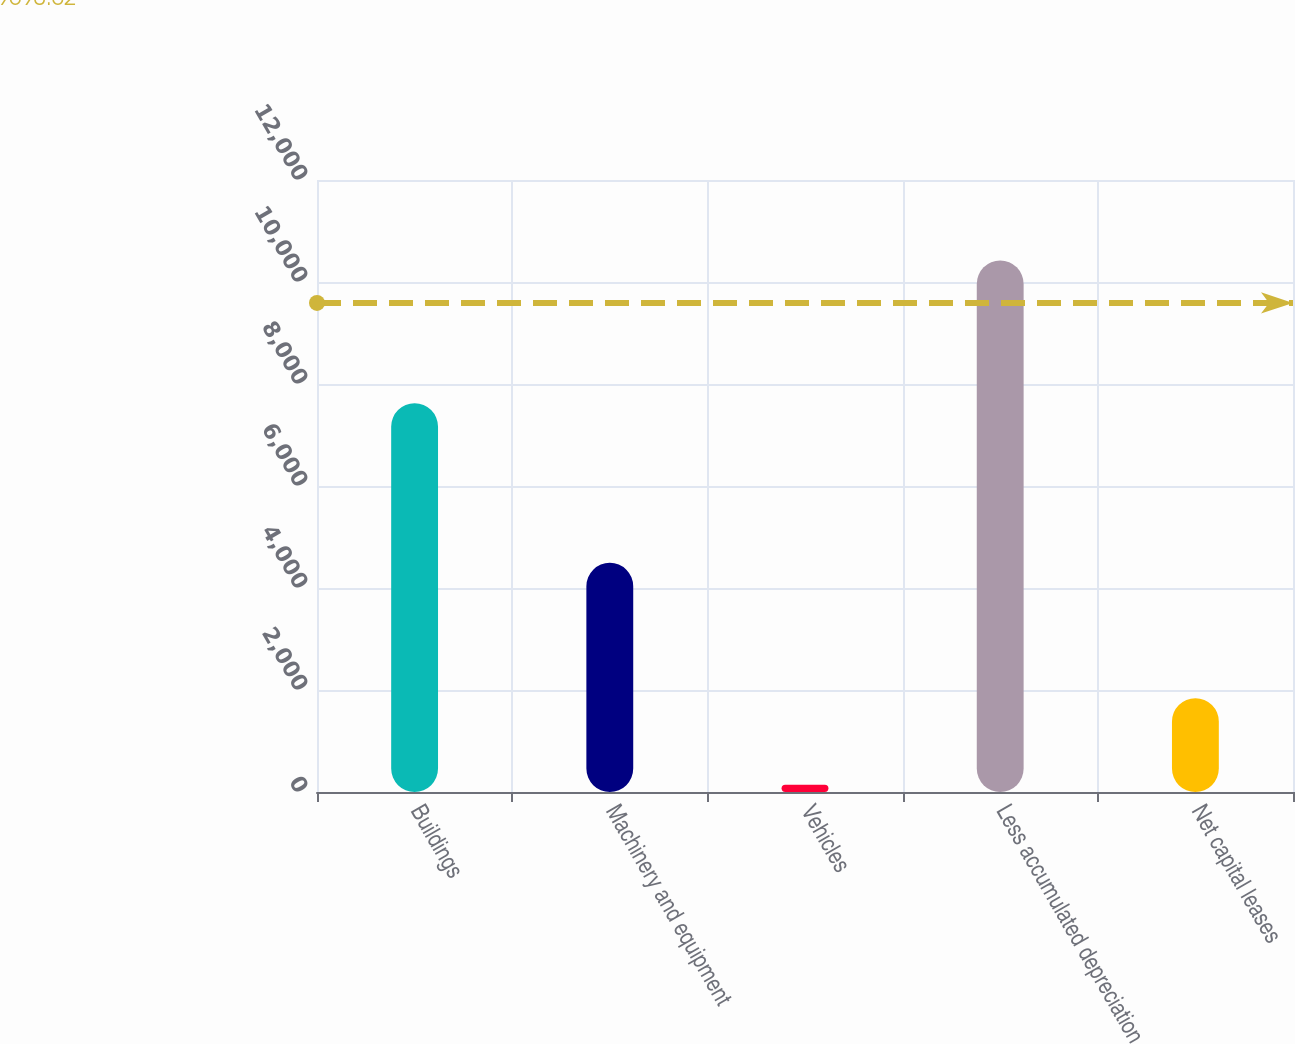<chart> <loc_0><loc_0><loc_500><loc_500><bar_chart><fcel>Buildings<fcel>Machinery and equipment<fcel>Vehicles<fcel>Less accumulated depreciation<fcel>Net capital leases<nl><fcel>7624<fcel>4494<fcel>144<fcel>10422<fcel>1840<nl></chart> 